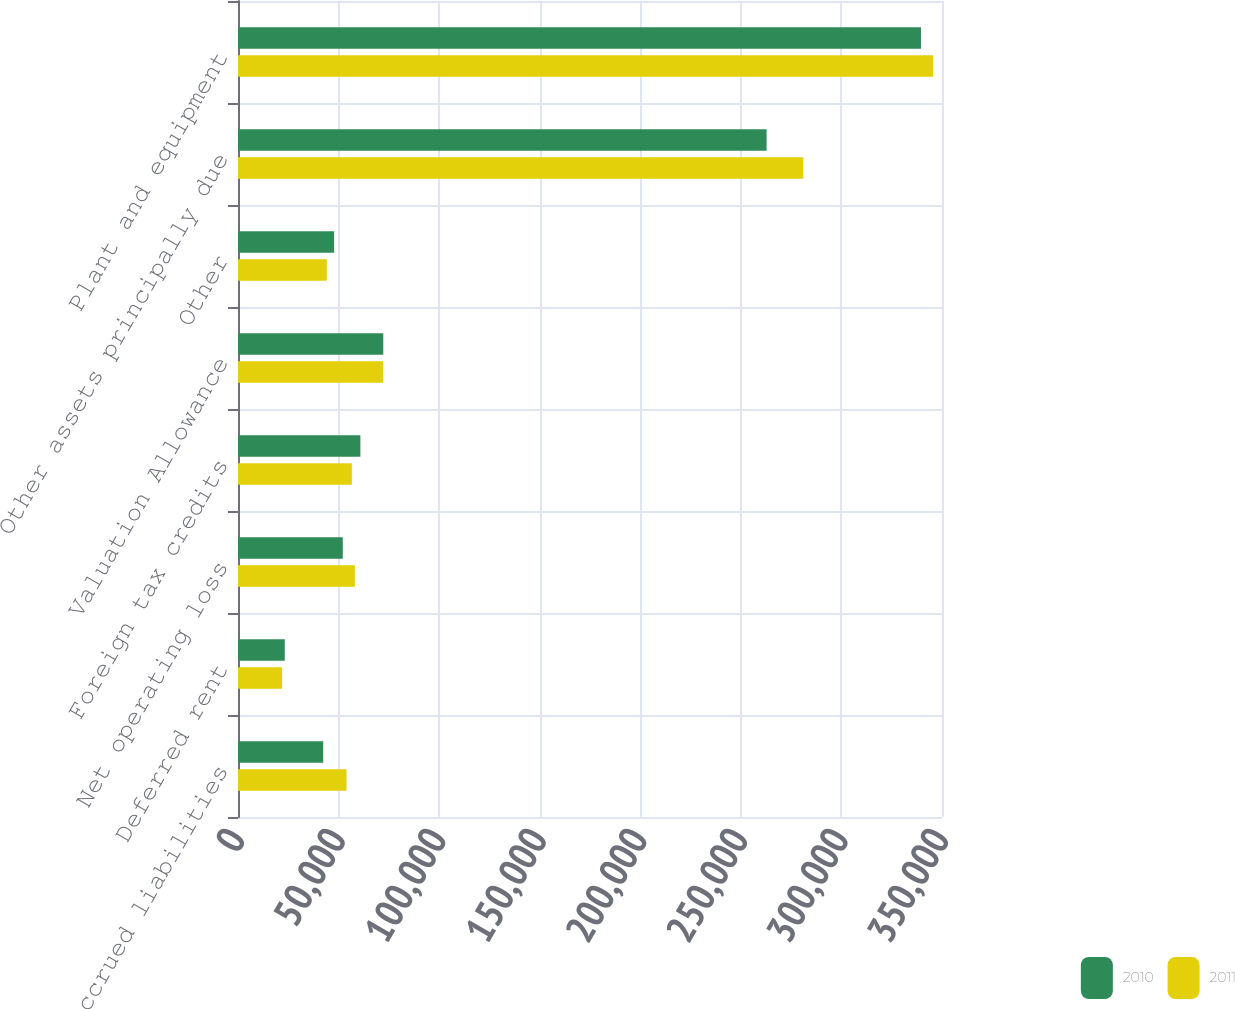Convert chart to OTSL. <chart><loc_0><loc_0><loc_500><loc_500><stacked_bar_chart><ecel><fcel>Accrued liabilities<fcel>Deferred rent<fcel>Net operating loss<fcel>Foreign tax credits<fcel>Valuation Allowance<fcel>Other<fcel>Other assets principally due<fcel>Plant and equipment<nl><fcel>2010<fcel>42360<fcel>23253<fcel>52099<fcel>60841<fcel>72229<fcel>47779<fcel>262801<fcel>339541<nl><fcel>2011<fcel>53983<fcel>21889<fcel>58113<fcel>56599<fcel>72239<fcel>44168<fcel>281060<fcel>345576<nl></chart> 